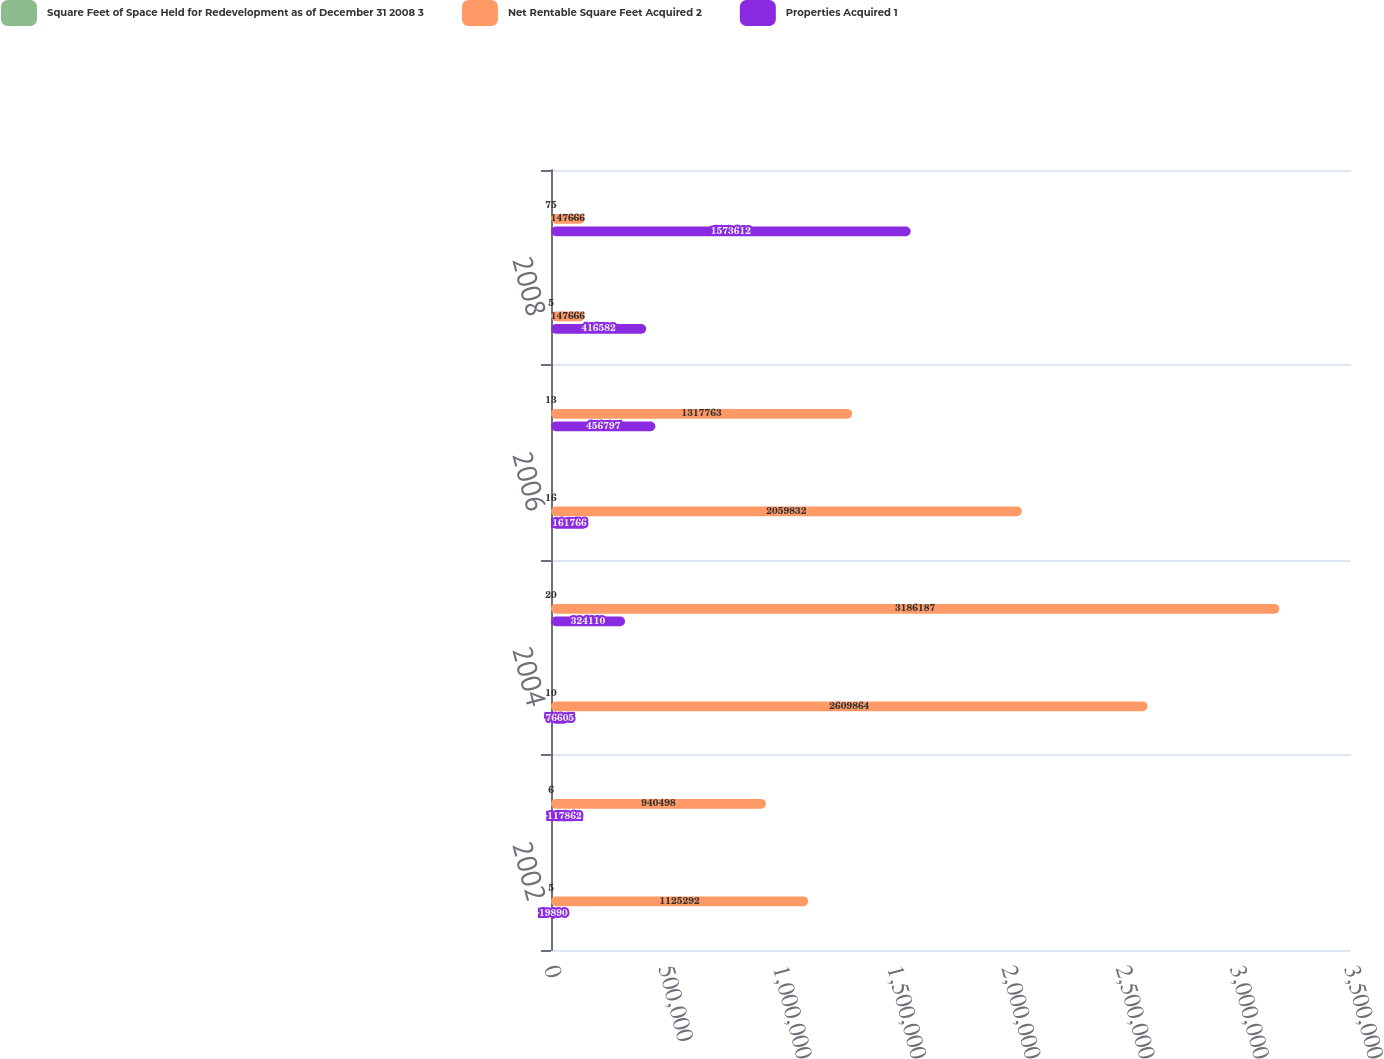Convert chart. <chart><loc_0><loc_0><loc_500><loc_500><stacked_bar_chart><ecel><fcel>2002<fcel>2003<fcel>2004<fcel>2005<fcel>2006<fcel>2007<fcel>2008<fcel>Properties owned as of<nl><fcel>Square Feet of Space Held for Redevelopment as of December 31 2008 3<fcel>5<fcel>6<fcel>10<fcel>20<fcel>16<fcel>13<fcel>5<fcel>75<nl><fcel>Net Rentable Square Feet Acquired 2<fcel>1.12529e+06<fcel>940498<fcel>2.60986e+06<fcel>3.18619e+06<fcel>2.05983e+06<fcel>1.31776e+06<fcel>147666<fcel>147666<nl><fcel>Properties Acquired 1<fcel>19890<fcel>117862<fcel>76605<fcel>324110<fcel>161766<fcel>456797<fcel>416582<fcel>1.57361e+06<nl></chart> 